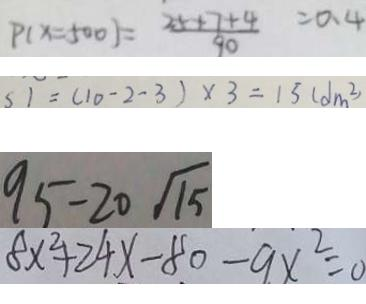Convert formula to latex. <formula><loc_0><loc_0><loc_500><loc_500>P ( x = 5 0 0 ) = \frac { 2 5 + 7 + 4 } { 9 0 } = 0 . 4 
 S 1 = ( 1 0 - 2 - 3 ) \times 3 = 1 5 ( d m ^ { 2 } ) 
 9 5 - 2 0 \sqrt { 1 5 } 
 8 x ^ { 2 } + 2 4 x - 8 0 - 9 x ^ { 2 } = 0</formula> 